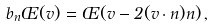Convert formula to latex. <formula><loc_0><loc_0><loc_500><loc_500>b _ { n } \phi ( { v } ) = \phi ( { v } - 2 ( { v } \cdot { n } ) { n } ) \, ,</formula> 